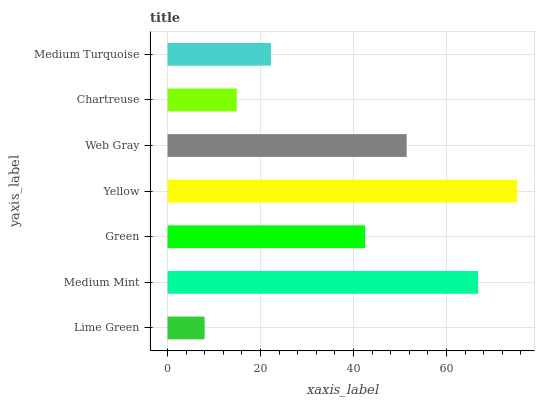Is Lime Green the minimum?
Answer yes or no. Yes. Is Yellow the maximum?
Answer yes or no. Yes. Is Medium Mint the minimum?
Answer yes or no. No. Is Medium Mint the maximum?
Answer yes or no. No. Is Medium Mint greater than Lime Green?
Answer yes or no. Yes. Is Lime Green less than Medium Mint?
Answer yes or no. Yes. Is Lime Green greater than Medium Mint?
Answer yes or no. No. Is Medium Mint less than Lime Green?
Answer yes or no. No. Is Green the high median?
Answer yes or no. Yes. Is Green the low median?
Answer yes or no. Yes. Is Lime Green the high median?
Answer yes or no. No. Is Medium Mint the low median?
Answer yes or no. No. 